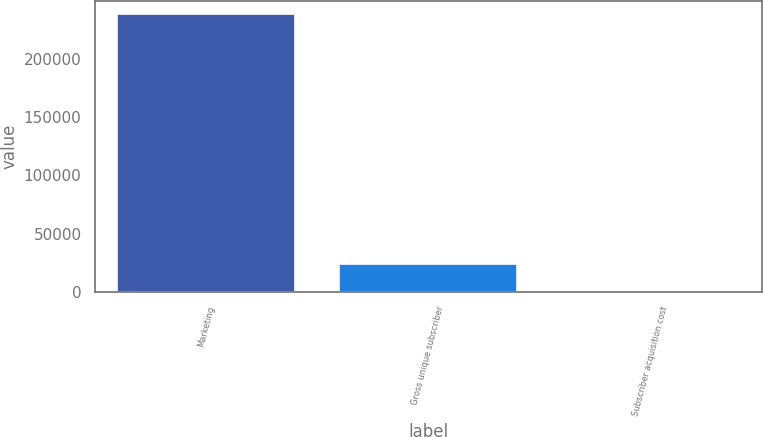Convert chart. <chart><loc_0><loc_0><loc_500><loc_500><bar_chart><fcel>Marketing<fcel>Gross unique subscriber<fcel>Subscriber acquisition cost<nl><fcel>237744<fcel>23797.3<fcel>25.48<nl></chart> 